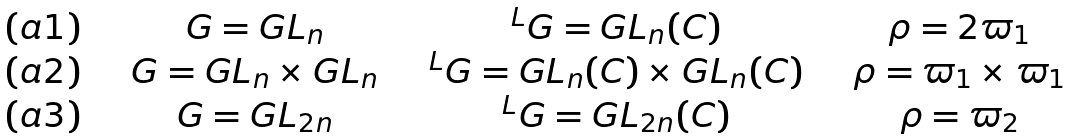Convert formula to latex. <formula><loc_0><loc_0><loc_500><loc_500>\begin{matrix} ( { a 1 } ) & & & G = G L _ { n } & & & ^ { L } G = G L _ { n } ( { C } ) & & & \rho = 2 \varpi _ { 1 } \\ ( { a 2 } ) & & & G = G L _ { n } \times G L _ { n } & & & ^ { L } G = G L _ { n } ( { C } ) \times G L _ { n } ( { C } ) & & & \rho = \varpi _ { 1 } \times \varpi _ { 1 } \\ ( { a 3 } ) & & & G = G L _ { 2 n } & & & ^ { L } G = G L _ { 2 n } ( { C } ) & & & \rho = \varpi _ { 2 } \end{matrix}</formula> 